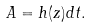<formula> <loc_0><loc_0><loc_500><loc_500>A = h ( z ) d t .</formula> 